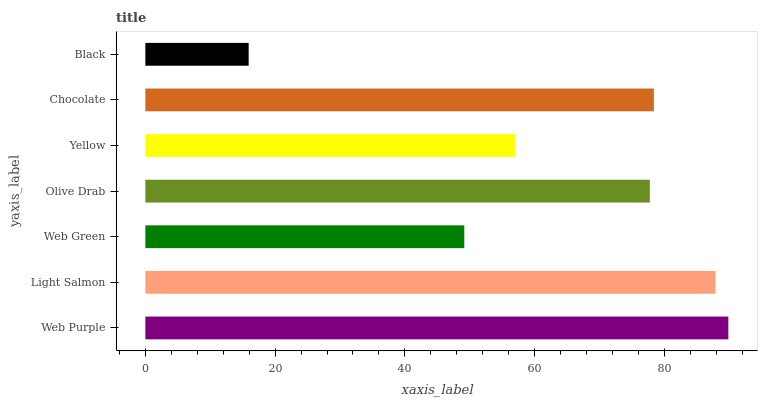Is Black the minimum?
Answer yes or no. Yes. Is Web Purple the maximum?
Answer yes or no. Yes. Is Light Salmon the minimum?
Answer yes or no. No. Is Light Salmon the maximum?
Answer yes or no. No. Is Web Purple greater than Light Salmon?
Answer yes or no. Yes. Is Light Salmon less than Web Purple?
Answer yes or no. Yes. Is Light Salmon greater than Web Purple?
Answer yes or no. No. Is Web Purple less than Light Salmon?
Answer yes or no. No. Is Olive Drab the high median?
Answer yes or no. Yes. Is Olive Drab the low median?
Answer yes or no. Yes. Is Web Purple the high median?
Answer yes or no. No. Is Web Purple the low median?
Answer yes or no. No. 